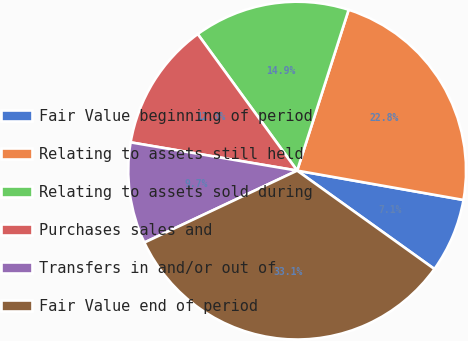<chart> <loc_0><loc_0><loc_500><loc_500><pie_chart><fcel>Fair Value beginning of period<fcel>Relating to assets still held<fcel>Relating to assets sold during<fcel>Purchases sales and<fcel>Transfers in and/or out of<fcel>Fair Value end of period<nl><fcel>7.12%<fcel>22.85%<fcel>14.95%<fcel>12.31%<fcel>9.68%<fcel>33.1%<nl></chart> 